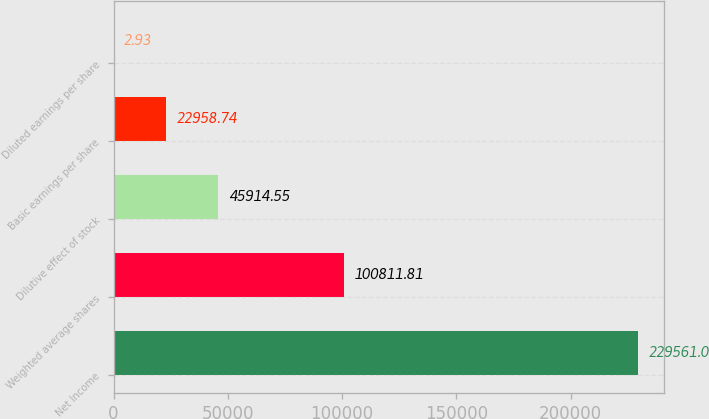Convert chart. <chart><loc_0><loc_0><loc_500><loc_500><bar_chart><fcel>Net Income<fcel>Weighted average shares<fcel>Dilutive effect of stock<fcel>Basic earnings per share<fcel>Diluted earnings per share<nl><fcel>229561<fcel>100812<fcel>45914.6<fcel>22958.7<fcel>2.93<nl></chart> 